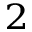Convert formula to latex. <formula><loc_0><loc_0><loc_500><loc_500>_ { 2 }</formula> 